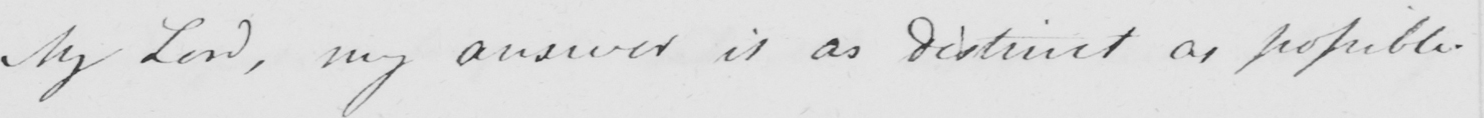Please provide the text content of this handwritten line. My Lord , my answer is as distinct as possible . 